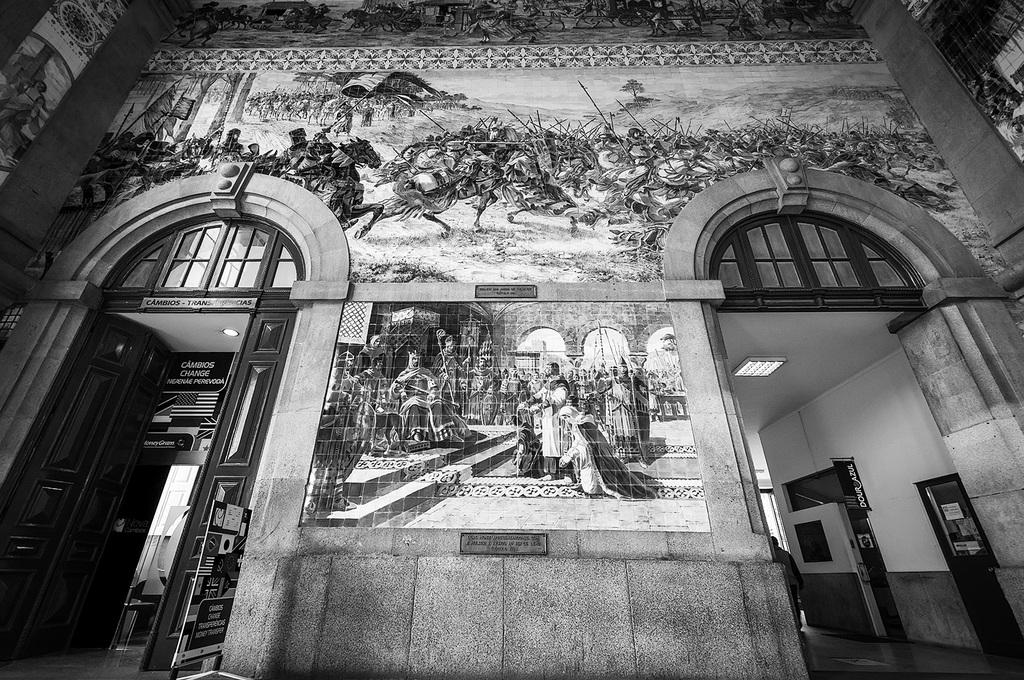What type of structure can be seen in the image? There is a door and a wall in the image. What is hanging on the wall in the image? There is an art piece on the wall in the image. What is the color scheme of the image? The image is black and white in color. How many family members are visible in the image? There are no family members present in the image; it only features a door, a wall, and an art piece. What type of tax is being discussed in the image? There is no discussion of tax in the image; it is a black and white image of a door, a wall, and an art piece. 